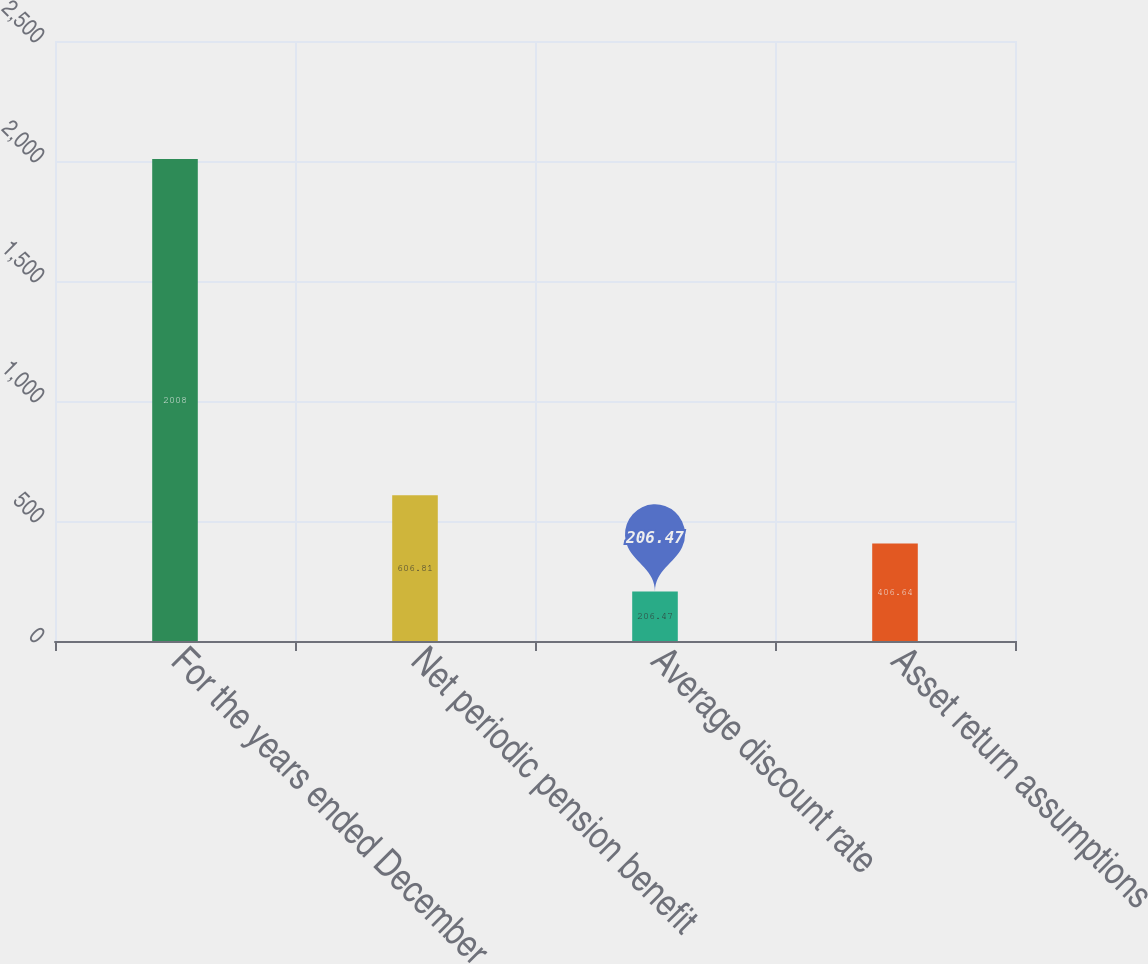Convert chart. <chart><loc_0><loc_0><loc_500><loc_500><bar_chart><fcel>For the years ended December<fcel>Net periodic pension benefit<fcel>Average discount rate<fcel>Asset return assumptions<nl><fcel>2008<fcel>606.81<fcel>206.47<fcel>406.64<nl></chart> 